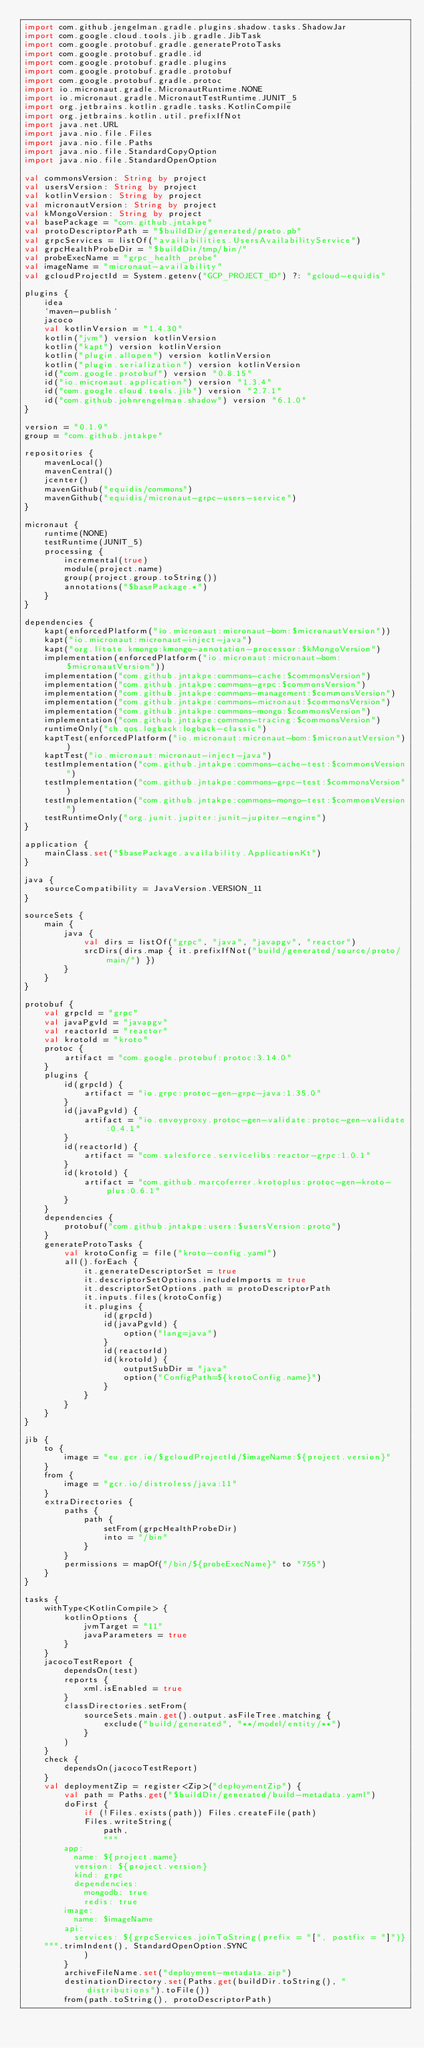Convert code to text. <code><loc_0><loc_0><loc_500><loc_500><_Kotlin_>import com.github.jengelman.gradle.plugins.shadow.tasks.ShadowJar
import com.google.cloud.tools.jib.gradle.JibTask
import com.google.protobuf.gradle.generateProtoTasks
import com.google.protobuf.gradle.id
import com.google.protobuf.gradle.plugins
import com.google.protobuf.gradle.protobuf
import com.google.protobuf.gradle.protoc
import io.micronaut.gradle.MicronautRuntime.NONE
import io.micronaut.gradle.MicronautTestRuntime.JUNIT_5
import org.jetbrains.kotlin.gradle.tasks.KotlinCompile
import org.jetbrains.kotlin.util.prefixIfNot
import java.net.URL
import java.nio.file.Files
import java.nio.file.Paths
import java.nio.file.StandardCopyOption
import java.nio.file.StandardOpenOption

val commonsVersion: String by project
val usersVersion: String by project
val kotlinVersion: String by project
val micronautVersion: String by project
val kMongoVersion: String by project
val basePackage = "com.github.jntakpe"
val protoDescriptorPath = "$buildDir/generated/proto.pb"
val grpcServices = listOf("availabilities.UsersAvailabilityService")
val grpcHealthProbeDir = "$buildDir/tmp/bin/"
val probeExecName = "grpc_health_probe"
val imageName = "micronaut-availability"
val gcloudProjectId = System.getenv("GCP_PROJECT_ID") ?: "gcloud-equidis"

plugins {
    idea
    `maven-publish`
    jacoco
    val kotlinVersion = "1.4.30"
    kotlin("jvm") version kotlinVersion
    kotlin("kapt") version kotlinVersion
    kotlin("plugin.allopen") version kotlinVersion
    kotlin("plugin.serialization") version kotlinVersion
    id("com.google.protobuf") version "0.8.15"
    id("io.micronaut.application") version "1.3.4"
    id("com.google.cloud.tools.jib") version "2.7.1"
    id("com.github.johnrengelman.shadow") version "6.1.0"
}

version = "0.1.9"
group = "com.github.jntakpe"

repositories {
    mavenLocal()
    mavenCentral()
    jcenter()
    mavenGithub("equidis/commons")
    mavenGithub("equidis/micronaut-grpc-users-service")
}

micronaut {
    runtime(NONE)
    testRuntime(JUNIT_5)
    processing {
        incremental(true)
        module(project.name)
        group(project.group.toString())
        annotations("$basePackage.*")
    }
}

dependencies {
    kapt(enforcedPlatform("io.micronaut:micronaut-bom:$micronautVersion"))
    kapt("io.micronaut:micronaut-inject-java")
    kapt("org.litote.kmongo:kmongo-annotation-processor:$kMongoVersion")
    implementation(enforcedPlatform("io.micronaut:micronaut-bom:$micronautVersion"))
    implementation("com.github.jntakpe:commons-cache:$commonsVersion")
    implementation("com.github.jntakpe:commons-grpc:$commonsVersion")
    implementation("com.github.jntakpe:commons-management:$commonsVersion")
    implementation("com.github.jntakpe:commons-micronaut:$commonsVersion")
    implementation("com.github.jntakpe:commons-mongo:$commonsVersion")
    implementation("com.github.jntakpe:commons-tracing:$commonsVersion")
    runtimeOnly("ch.qos.logback:logback-classic")
    kaptTest(enforcedPlatform("io.micronaut:micronaut-bom:$micronautVersion"))
    kaptTest("io.micronaut:micronaut-inject-java")
    testImplementation("com.github.jntakpe:commons-cache-test:$commonsVersion")
    testImplementation("com.github.jntakpe:commons-grpc-test:$commonsVersion")
    testImplementation("com.github.jntakpe:commons-mongo-test:$commonsVersion")
    testRuntimeOnly("org.junit.jupiter:junit-jupiter-engine")
}

application {
    mainClass.set("$basePackage.availability.ApplicationKt")
}

java {
    sourceCompatibility = JavaVersion.VERSION_11
}

sourceSets {
    main {
        java {
            val dirs = listOf("grpc", "java", "javapgv", "reactor")
            srcDirs(dirs.map { it.prefixIfNot("build/generated/source/proto/main/") })
        }
    }
}

protobuf {
    val grpcId = "grpc"
    val javaPgvId = "javapgv"
    val reactorId = "reactor"
    val krotoId = "kroto"
    protoc {
        artifact = "com.google.protobuf:protoc:3.14.0"
    }
    plugins {
        id(grpcId) {
            artifact = "io.grpc:protoc-gen-grpc-java:1.35.0"
        }
        id(javaPgvId) {
            artifact = "io.envoyproxy.protoc-gen-validate:protoc-gen-validate:0.4.1"
        }
        id(reactorId) {
            artifact = "com.salesforce.servicelibs:reactor-grpc:1.0.1"
        }
        id(krotoId) {
            artifact = "com.github.marcoferrer.krotoplus:protoc-gen-kroto-plus:0.6.1"
        }
    }
    dependencies {
        protobuf("com.github.jntakpe:users:$usersVersion:proto")
    }
    generateProtoTasks {
        val krotoConfig = file("kroto-config.yaml")
        all().forEach {
            it.generateDescriptorSet = true
            it.descriptorSetOptions.includeImports = true
            it.descriptorSetOptions.path = protoDescriptorPath
            it.inputs.files(krotoConfig)
            it.plugins {
                id(grpcId)
                id(javaPgvId) {
                    option("lang=java")
                }
                id(reactorId)
                id(krotoId) {
                    outputSubDir = "java"
                    option("ConfigPath=${krotoConfig.name}")
                }
            }
        }
    }
}

jib {
    to {
        image = "eu.gcr.io/$gcloudProjectId/$imageName:${project.version}"
    }
    from {
        image = "gcr.io/distroless/java:11"
    }
    extraDirectories {
        paths {
            path {
                setFrom(grpcHealthProbeDir)
                into = "/bin"
            }
        }
        permissions = mapOf("/bin/${probeExecName}" to "755")
    }
}

tasks {
    withType<KotlinCompile> {
        kotlinOptions {
            jvmTarget = "11"
            javaParameters = true
        }
    }
    jacocoTestReport {
        dependsOn(test)
        reports {
            xml.isEnabled = true
        }
        classDirectories.setFrom(
            sourceSets.main.get().output.asFileTree.matching {
                exclude("build/generated", "**/model/entity/**")
            }
        )
    }
    check {
        dependsOn(jacocoTestReport)
    }
    val deploymentZip = register<Zip>("deploymentZip") {
        val path = Paths.get("$buildDir/generated/build-metadata.yaml")
        doFirst {
            if (!Files.exists(path)) Files.createFile(path)
            Files.writeString(
                path,
                """
        app:
          name: ${project.name}
          version: ${project.version}
          kind: grpc
          dependencies:
            mongodb: true
            redis: true
        image:
          name: $imageName
        api:
          services: ${grpcServices.joinToString(prefix = "[", postfix = "]")}
    """.trimIndent(), StandardOpenOption.SYNC
            )
        }
        archiveFileName.set("deployment-metadata.zip")
        destinationDirectory.set(Paths.get(buildDir.toString(), "distributions").toFile())
        from(path.toString(), protoDescriptorPath)</code> 